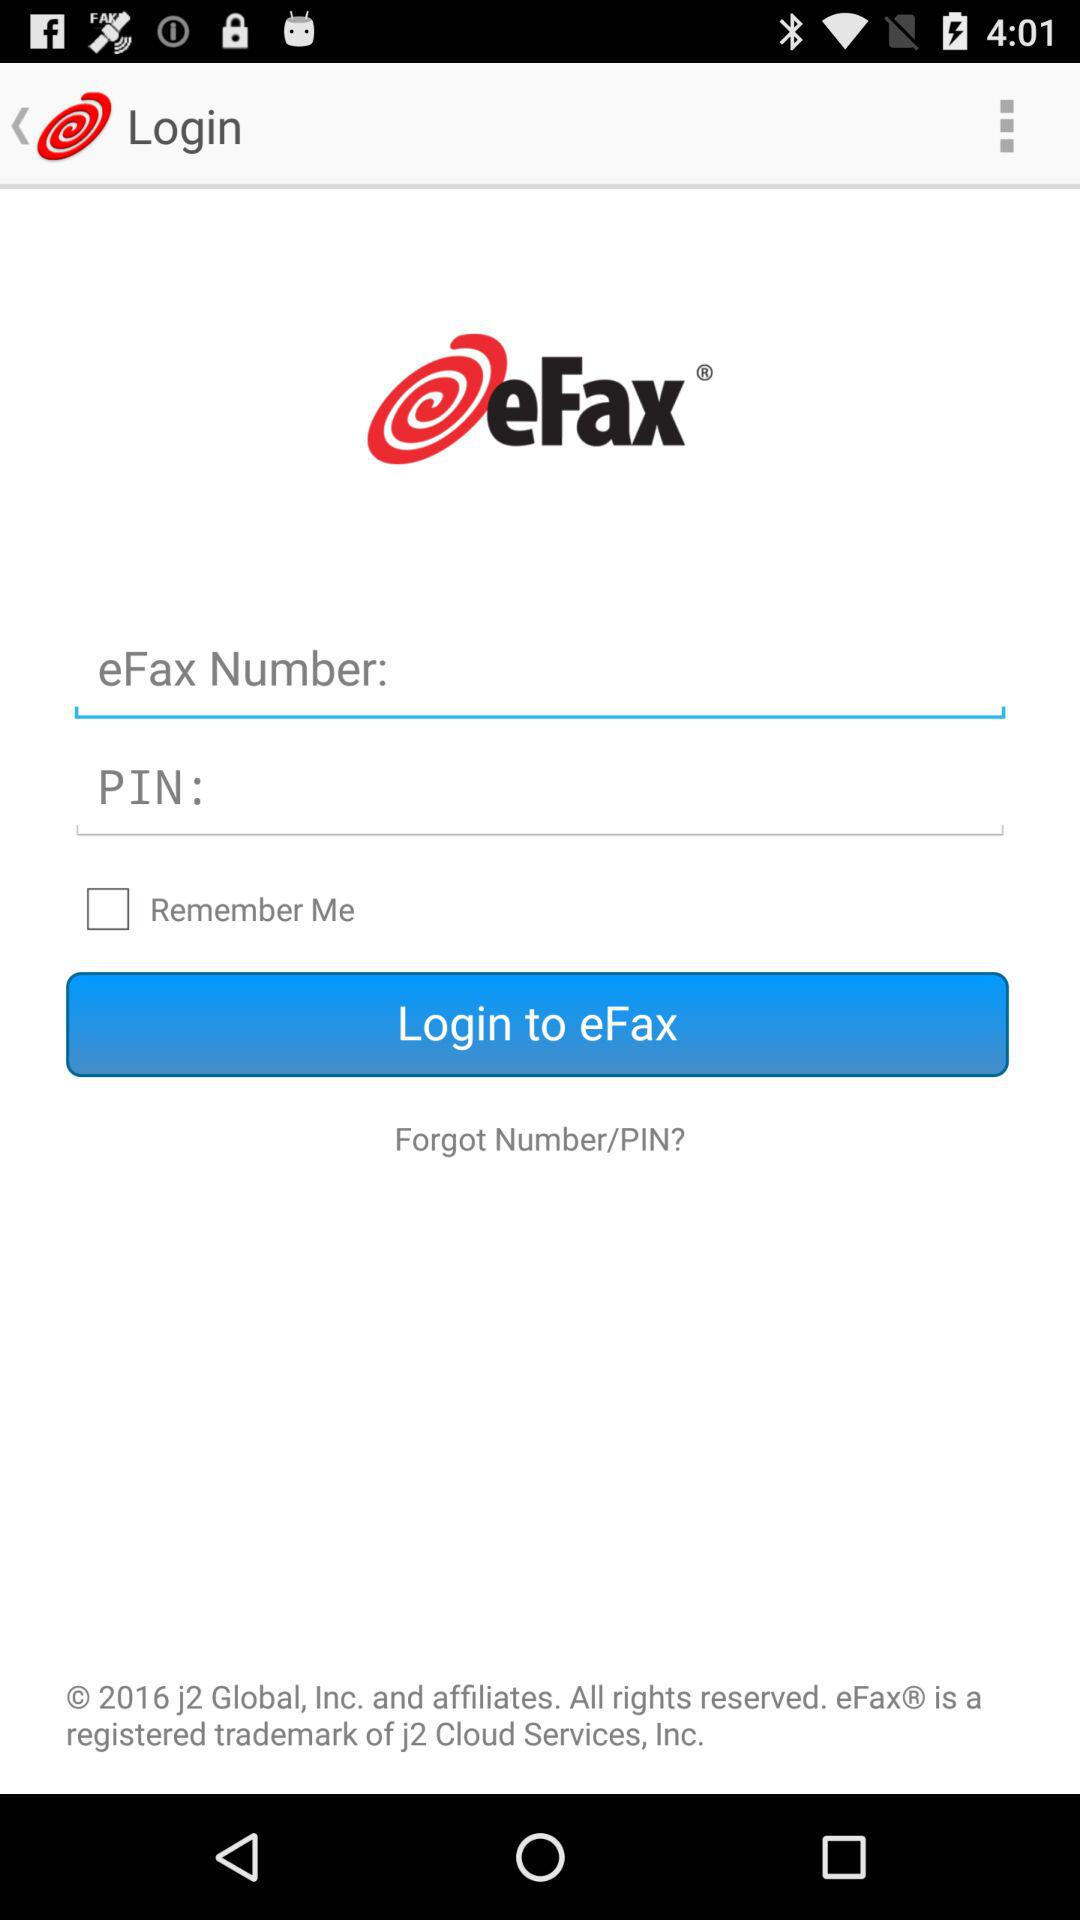What's the status of "Remember Me"? The status of "Remember Me" is "off". 